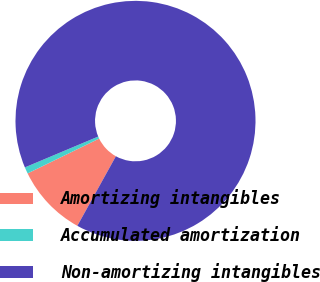Convert chart to OTSL. <chart><loc_0><loc_0><loc_500><loc_500><pie_chart><fcel>Amortizing intangibles<fcel>Accumulated amortization<fcel>Non-amortizing intangibles<nl><fcel>9.73%<fcel>0.88%<fcel>89.39%<nl></chart> 